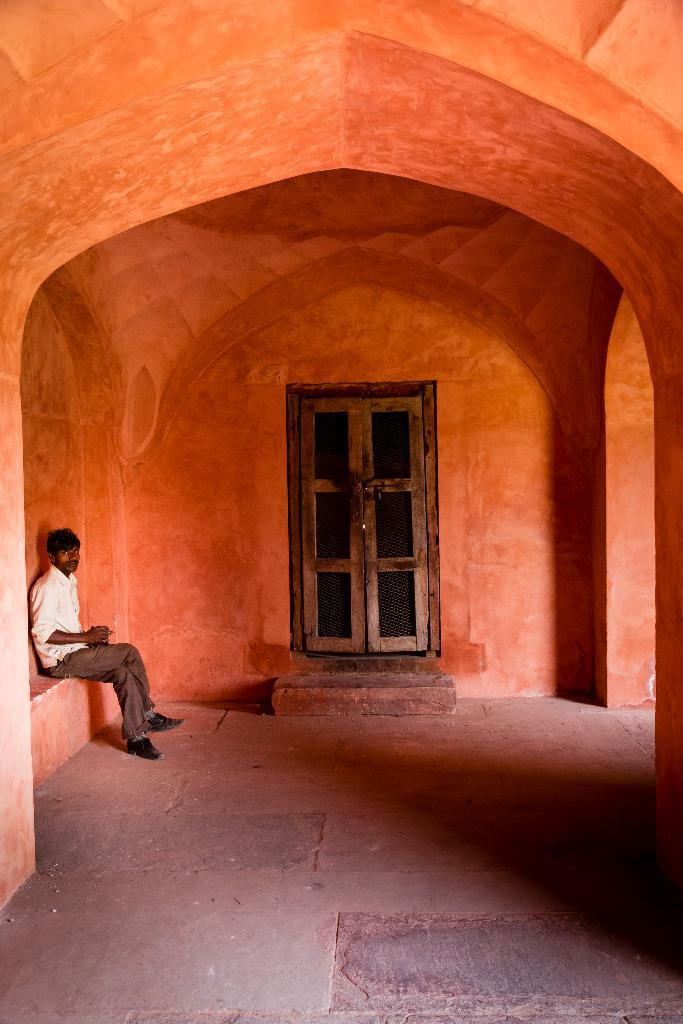What type of structure is depicted in the image? There is an arch in the image, along with pillars and a wall with doors. Can you describe the architectural elements in the image? The image features an arch, pillars, and a wall with doors. Is there anyone present in the image? Yes, a person is sitting in the image. What type of playground equipment can be seen in the image? There is no playground equipment present in the image. What subject is the person teaching in the image? There is no indication of teaching or any subject in the image. 